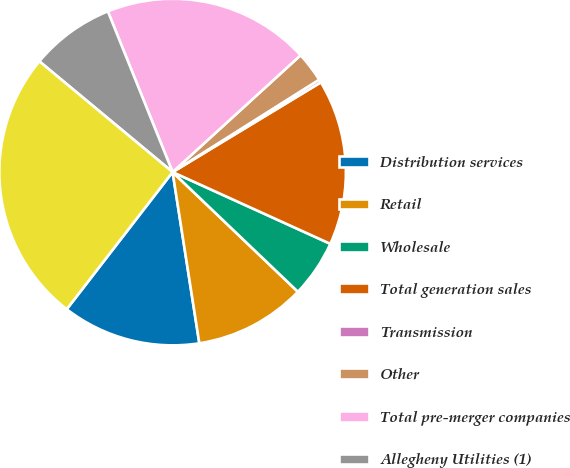Convert chart to OTSL. <chart><loc_0><loc_0><loc_500><loc_500><pie_chart><fcel>Distribution services<fcel>Retail<fcel>Wholesale<fcel>Total generation sales<fcel>Transmission<fcel>Other<fcel>Total pre-merger companies<fcel>Allegheny Utilities (1)<fcel>Total Revenues<nl><fcel>12.93%<fcel>10.4%<fcel>5.34%<fcel>15.46%<fcel>0.29%<fcel>2.82%<fcel>19.32%<fcel>7.87%<fcel>25.57%<nl></chart> 